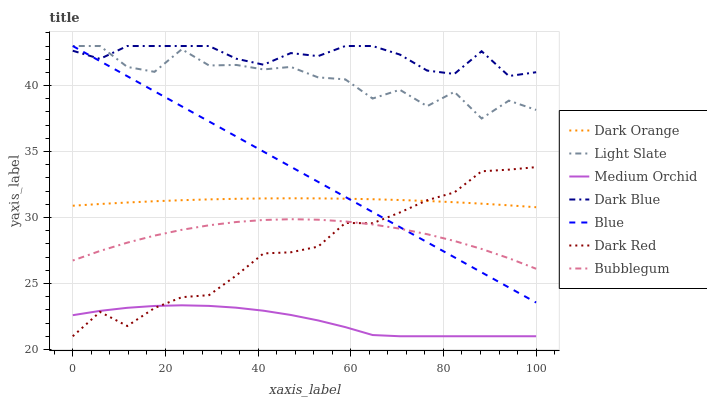Does Medium Orchid have the minimum area under the curve?
Answer yes or no. Yes. Does Dark Blue have the maximum area under the curve?
Answer yes or no. Yes. Does Dark Orange have the minimum area under the curve?
Answer yes or no. No. Does Dark Orange have the maximum area under the curve?
Answer yes or no. No. Is Blue the smoothest?
Answer yes or no. Yes. Is Light Slate the roughest?
Answer yes or no. Yes. Is Dark Orange the smoothest?
Answer yes or no. No. Is Dark Orange the roughest?
Answer yes or no. No. Does Dark Red have the lowest value?
Answer yes or no. Yes. Does Dark Orange have the lowest value?
Answer yes or no. No. Does Dark Blue have the highest value?
Answer yes or no. Yes. Does Dark Orange have the highest value?
Answer yes or no. No. Is Bubblegum less than Dark Orange?
Answer yes or no. Yes. Is Dark Blue greater than Medium Orchid?
Answer yes or no. Yes. Does Dark Orange intersect Blue?
Answer yes or no. Yes. Is Dark Orange less than Blue?
Answer yes or no. No. Is Dark Orange greater than Blue?
Answer yes or no. No. Does Bubblegum intersect Dark Orange?
Answer yes or no. No. 